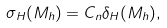Convert formula to latex. <formula><loc_0><loc_0><loc_500><loc_500>\sigma _ { H } ( M _ { h } ) = C _ { n } \delta _ { H } ( M _ { h } ) ,</formula> 